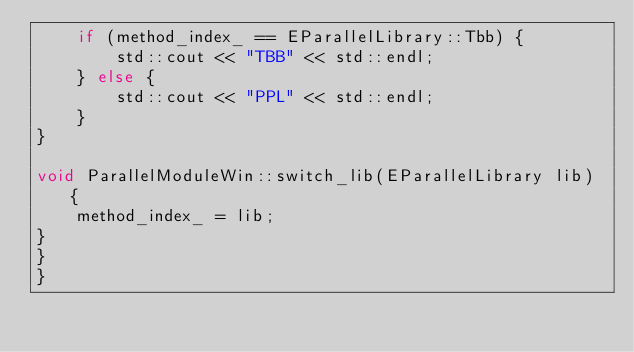<code> <loc_0><loc_0><loc_500><loc_500><_C++_>    if (method_index_ == EParallelLibrary::Tbb) {
        std::cout << "TBB" << std::endl;
    } else {
        std::cout << "PPL" << std::endl;
    }
}

void ParallelModuleWin::switch_lib(EParallelLibrary lib) {
    method_index_ = lib;
}
}
}
</code> 